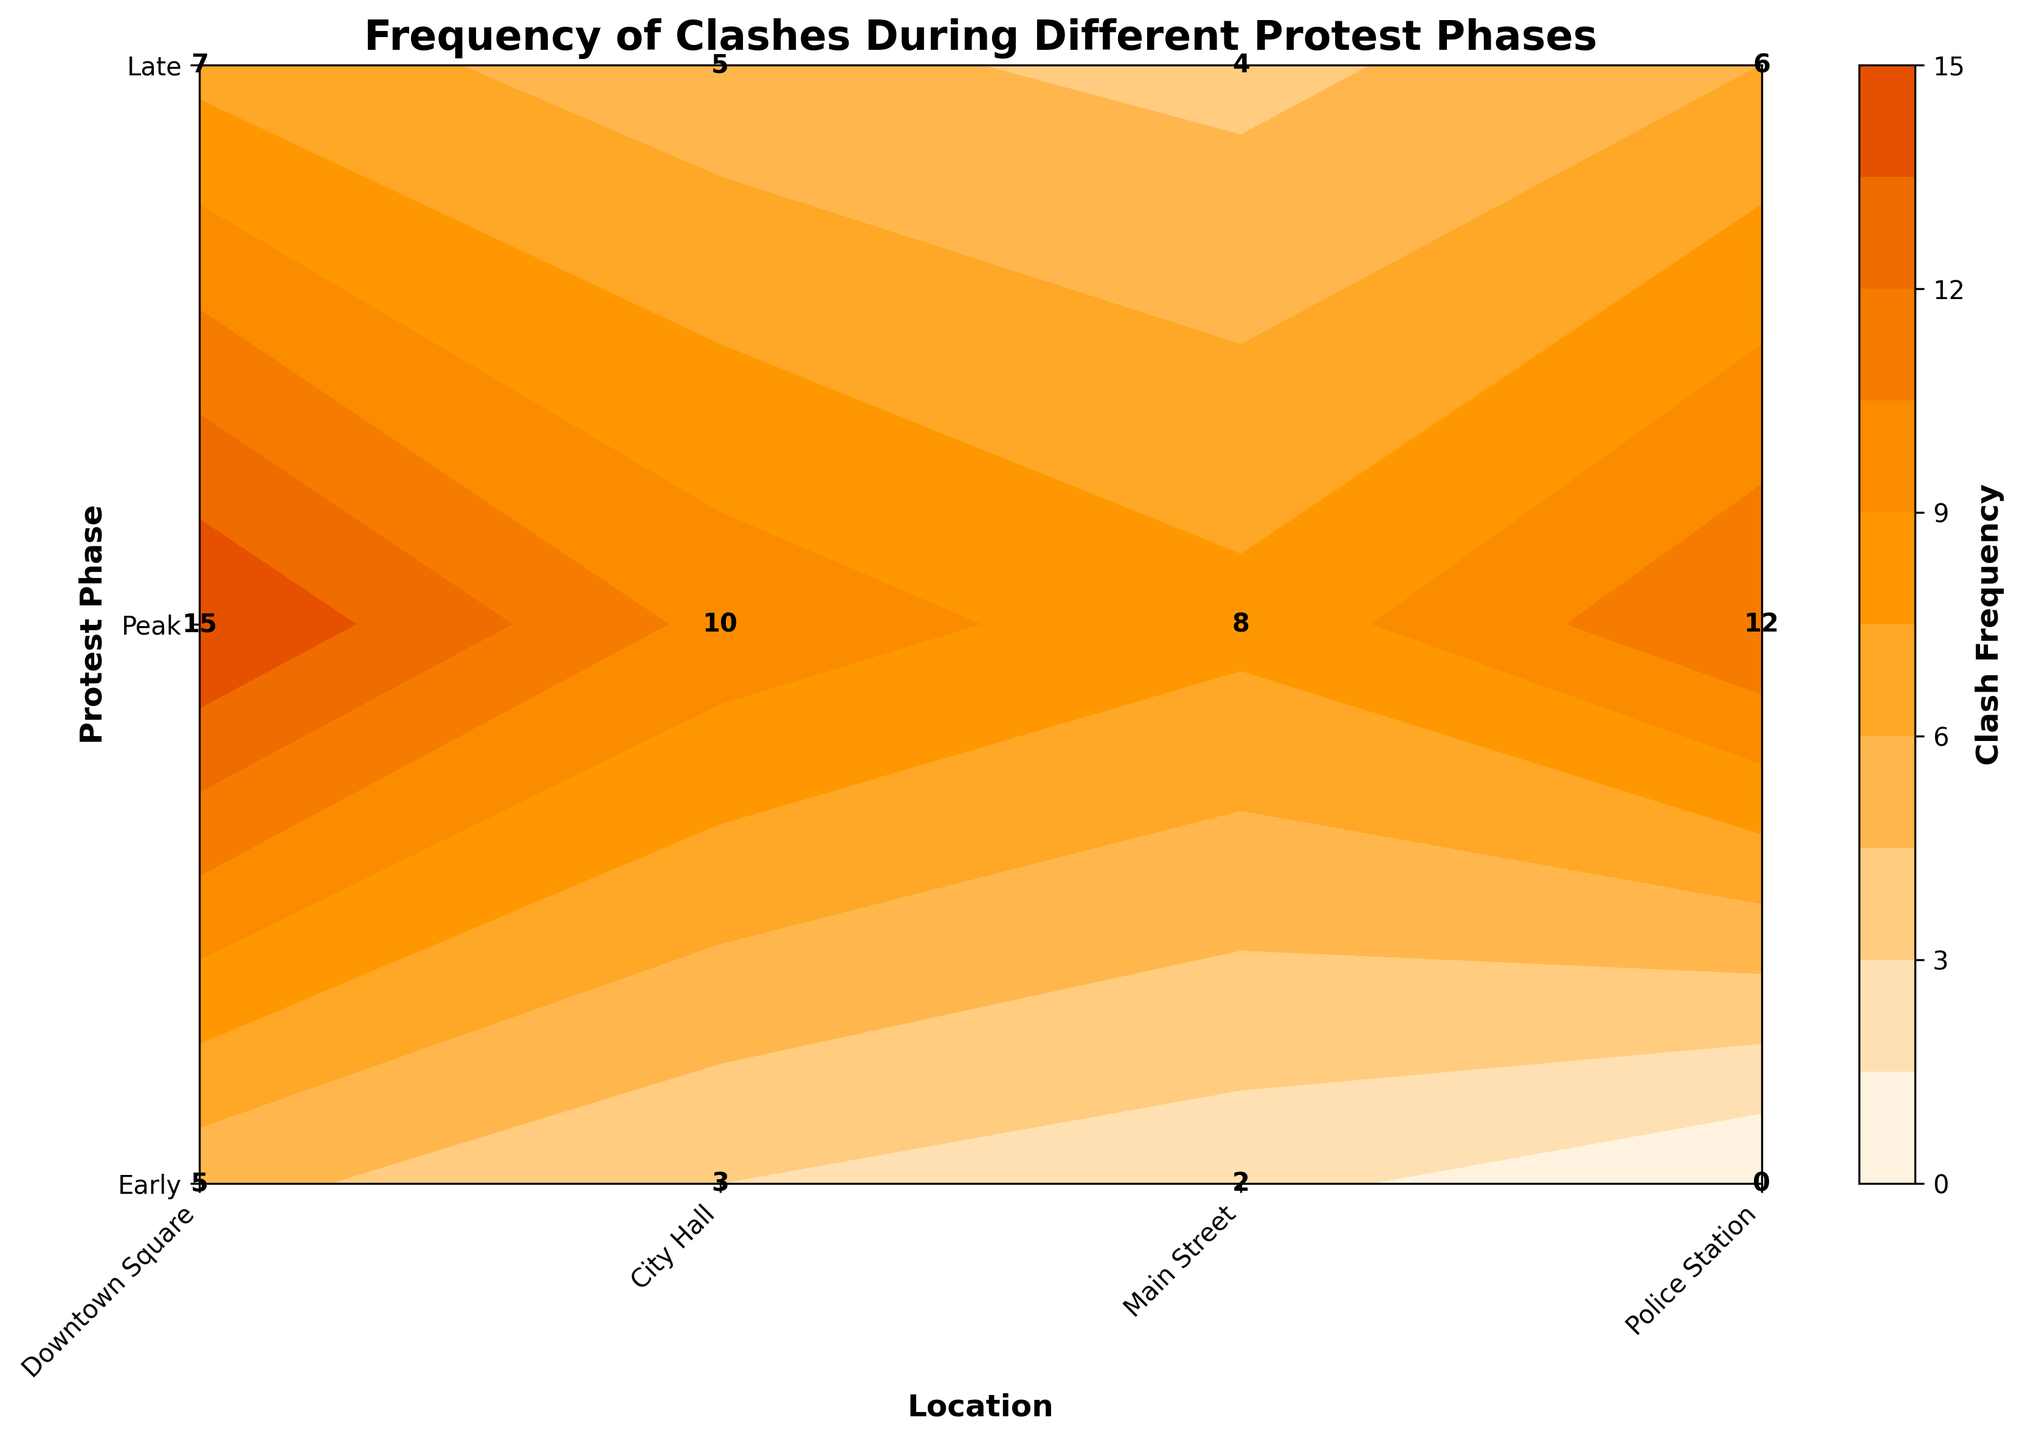What's the title of the plot? The title is located at the top of the figure, which describes the main subject or data represented in the plot.
Answer: Frequency of Clashes During Different Protest Phases What do the axes represent? The x-axis represents different locations where clashes occurred, and the y-axis represents different phases of the protest event.
Answer: Locations and Protest Phases Which location had the highest frequency of clashes during the Early phase? In the Early phase represented on the y-axis, identify the highest value labeled among the different locations on the x-axis.
Answer: Downtown Square What is the clash frequency at the City Hall during the Peak phase? Find the intersection of City Hall on the x-axis and Peak phase on the y-axis, then read the label at that point.
Answer: 10 Which phase had the overall highest frequency of clashes and at what location? Compare the highest frequency values within each phase and identify the phase with the maximum value, then note the location.
Answer: Peak phase at Downtown Square How many total clashes occurred at the Police Station across all phases? Sum the frequencies of clashes at the Police Station for all protest phases (Early, Peak, Late).
Answer: 18 Which location had the least clash frequency during the Peak phase compared to other locations? Among the values for the Peak phase, find the location with the smallest number of clashes.
Answer: Main Street How does the clash frequency at City Hall change from Peak to Late phase? Identify and subtract the clash frequency of City Hall in the Late phase from the Peak phase to determine the change.
Answer: 5 (Decrease) What color represents the lowest frequency of clashes on the plot? Observe the color gradient in the contour plot's color bar and identify the color correlated with the lowest frequency range.
Answer: Lightest color (e.g., light orange or beige) What is the average clash frequency during the Peak phase? Sum the frequencies of all locations during the Peak phase and divide by the number of locations.
Answer: 11.25 